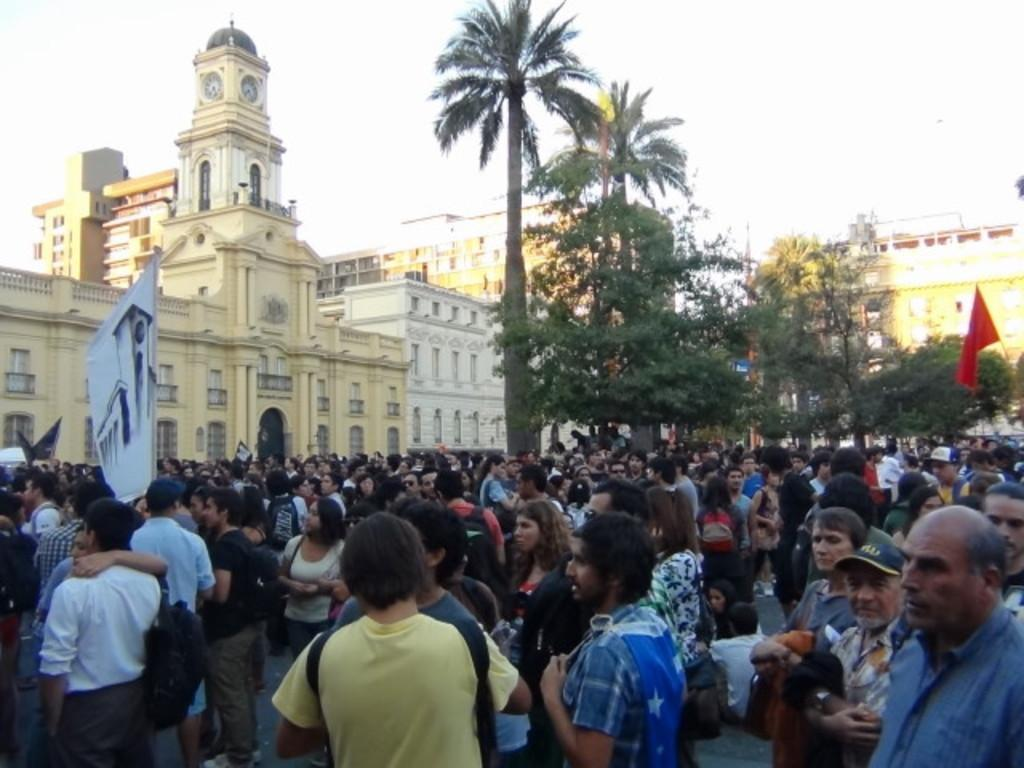What is happening with the group of people in the image? The group of people is on the ground in the image. What can be seen in the image besides the group of people? There is a banner and a flag in the image. What is visible in the background of the image? There are buildings, trees, and the sky visible in the background of the image. How many lizards are crawling on the stomach of the person in the image? There are no lizards or people visible in the image, so it is not possible to answer that question. 